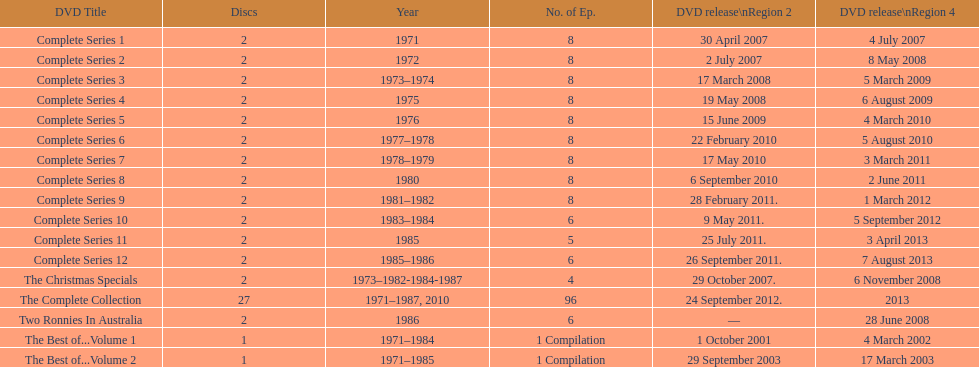The television show "the two ronnies" ran for a total of how many seasons? 12. 